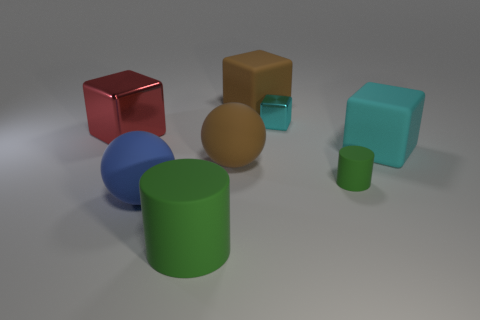What size is the cyan block that is made of the same material as the brown sphere?
Your answer should be very brief. Large. What size is the cyan matte thing that is the same shape as the large metallic object?
Your answer should be very brief. Large. Are there any small green matte objects?
Provide a short and direct response. Yes. How many objects are matte objects to the left of the cyan metal object or big objects?
Give a very brief answer. 6. There is a green object that is the same size as the cyan rubber thing; what is it made of?
Your response must be concise. Rubber. What color is the shiny thing to the left of the matte cylinder in front of the blue sphere?
Ensure brevity in your answer.  Red. What number of cyan rubber blocks are right of the small cyan metallic cube?
Give a very brief answer. 1. The small metal object has what color?
Provide a succinct answer. Cyan. What number of large things are cylinders or cyan things?
Give a very brief answer. 2. There is a block that is left of the brown matte cube; is it the same color as the matte block right of the small green rubber thing?
Make the answer very short. No. 